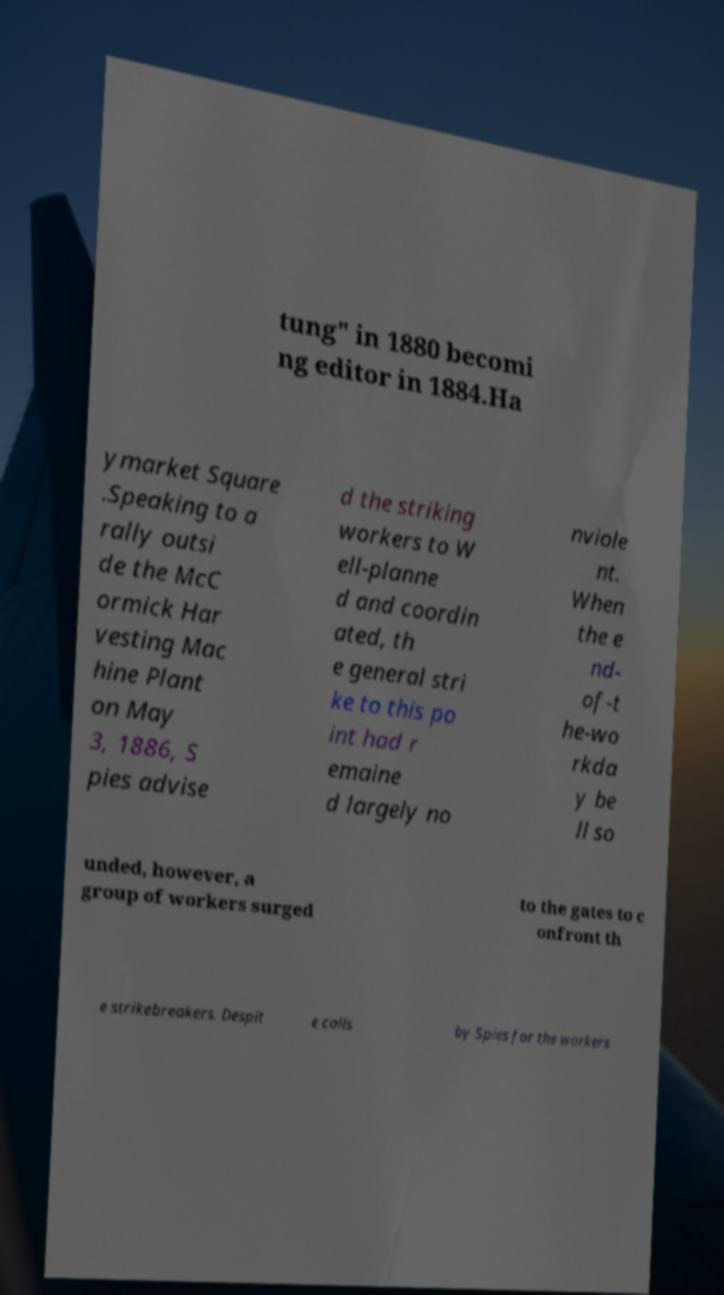Could you extract and type out the text from this image? tung" in 1880 becomi ng editor in 1884.Ha ymarket Square .Speaking to a rally outsi de the McC ormick Har vesting Mac hine Plant on May 3, 1886, S pies advise d the striking workers to W ell-planne d and coordin ated, th e general stri ke to this po int had r emaine d largely no nviole nt. When the e nd- of-t he-wo rkda y be ll so unded, however, a group of workers surged to the gates to c onfront th e strikebreakers. Despit e calls by Spies for the workers 